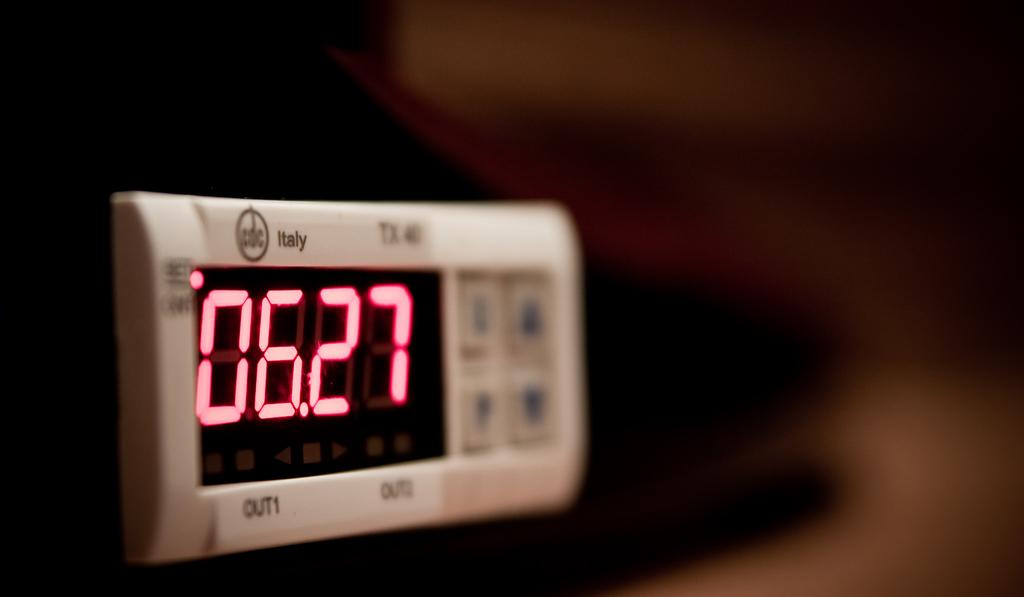<image>
Give a short and clear explanation of the subsequent image. A digital clock has Italy on the top with 06.27 displayed on the screen. 